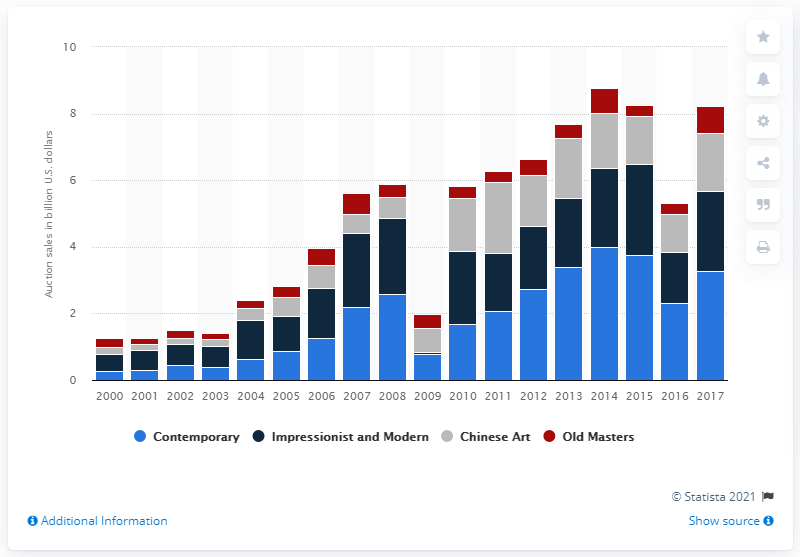Indicate a few pertinent items in this graphic. Christie's and Sotheby's auction sales began in the year 2000. In 2017, the amount of auction sales of Contemporary art was 3.28. 